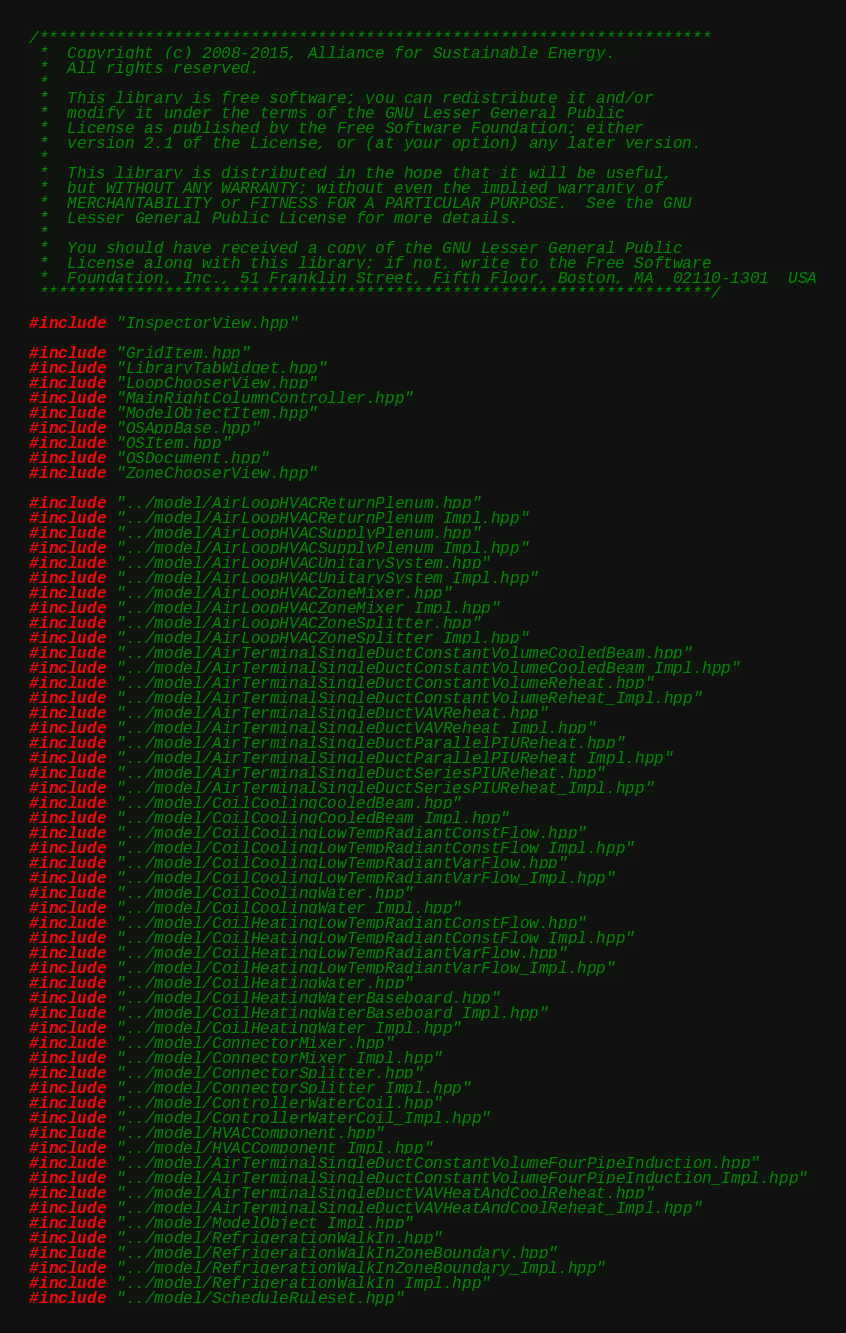Convert code to text. <code><loc_0><loc_0><loc_500><loc_500><_C++_>/**********************************************************************
 *  Copyright (c) 2008-2015, Alliance for Sustainable Energy.  
 *  All rights reserved.
 *  
 *  This library is free software; you can redistribute it and/or
 *  modify it under the terms of the GNU Lesser General Public
 *  License as published by the Free Software Foundation; either
 *  version 2.1 of the License, or (at your option) any later version.
 *  
 *  This library is distributed in the hope that it will be useful,
 *  but WITHOUT ANY WARRANTY; without even the implied warranty of
 *  MERCHANTABILITY or FITNESS FOR A PARTICULAR PURPOSE.  See the GNU
 *  Lesser General Public License for more details.
 *  
 *  You should have received a copy of the GNU Lesser General Public
 *  License along with this library; if not, write to the Free Software
 *  Foundation, Inc., 51 Franklin Street, Fifth Floor, Boston, MA  02110-1301  USA
 **********************************************************************/

#include "InspectorView.hpp"

#include "GridItem.hpp"
#include "LibraryTabWidget.hpp"
#include "LoopChooserView.hpp"
#include "MainRightColumnController.hpp"
#include "ModelObjectItem.hpp"
#include "OSAppBase.hpp"
#include "OSItem.hpp"
#include "OSDocument.hpp"
#include "ZoneChooserView.hpp"

#include "../model/AirLoopHVACReturnPlenum.hpp"
#include "../model/AirLoopHVACReturnPlenum_Impl.hpp"
#include "../model/AirLoopHVACSupplyPlenum.hpp"
#include "../model/AirLoopHVACSupplyPlenum_Impl.hpp"
#include "../model/AirLoopHVACUnitarySystem.hpp"
#include "../model/AirLoopHVACUnitarySystem_Impl.hpp"
#include "../model/AirLoopHVACZoneMixer.hpp"
#include "../model/AirLoopHVACZoneMixer_Impl.hpp"
#include "../model/AirLoopHVACZoneSplitter.hpp"
#include "../model/AirLoopHVACZoneSplitter_Impl.hpp"
#include "../model/AirTerminalSingleDuctConstantVolumeCooledBeam.hpp"
#include "../model/AirTerminalSingleDuctConstantVolumeCooledBeam_Impl.hpp"
#include "../model/AirTerminalSingleDuctConstantVolumeReheat.hpp"
#include "../model/AirTerminalSingleDuctConstantVolumeReheat_Impl.hpp"
#include "../model/AirTerminalSingleDuctVAVReheat.hpp"
#include "../model/AirTerminalSingleDuctVAVReheat_Impl.hpp"
#include "../model/AirTerminalSingleDuctParallelPIUReheat.hpp"
#include "../model/AirTerminalSingleDuctParallelPIUReheat_Impl.hpp"
#include "../model/AirTerminalSingleDuctSeriesPIUReheat.hpp"
#include "../model/AirTerminalSingleDuctSeriesPIUReheat_Impl.hpp"
#include "../model/CoilCoolingCooledBeam.hpp"
#include "../model/CoilCoolingCooledBeam_Impl.hpp"
#include "../model/CoilCoolingLowTempRadiantConstFlow.hpp"
#include "../model/CoilCoolingLowTempRadiantConstFlow_Impl.hpp"
#include "../model/CoilCoolingLowTempRadiantVarFlow.hpp"
#include "../model/CoilCoolingLowTempRadiantVarFlow_Impl.hpp"
#include "../model/CoilCoolingWater.hpp"
#include "../model/CoilCoolingWater_Impl.hpp"
#include "../model/CoilHeatingLowTempRadiantConstFlow.hpp"
#include "../model/CoilHeatingLowTempRadiantConstFlow_Impl.hpp"
#include "../model/CoilHeatingLowTempRadiantVarFlow.hpp"
#include "../model/CoilHeatingLowTempRadiantVarFlow_Impl.hpp"
#include "../model/CoilHeatingWater.hpp"
#include "../model/CoilHeatingWaterBaseboard.hpp"
#include "../model/CoilHeatingWaterBaseboard_Impl.hpp"
#include "../model/CoilHeatingWater_Impl.hpp"
#include "../model/ConnectorMixer.hpp"
#include "../model/ConnectorMixer_Impl.hpp"
#include "../model/ConnectorSplitter.hpp"
#include "../model/ConnectorSplitter_Impl.hpp"
#include "../model/ControllerWaterCoil.hpp"
#include "../model/ControllerWaterCoil_Impl.hpp"
#include "../model/HVACComponent.hpp"
#include "../model/HVACComponent_Impl.hpp"
#include "../model/AirTerminalSingleDuctConstantVolumeFourPipeInduction.hpp"
#include "../model/AirTerminalSingleDuctConstantVolumeFourPipeInduction_Impl.hpp"
#include "../model/AirTerminalSingleDuctVAVHeatAndCoolReheat.hpp"
#include "../model/AirTerminalSingleDuctVAVHeatAndCoolReheat_Impl.hpp"
#include "../model/ModelObject_Impl.hpp"
#include "../model/RefrigerationWalkIn.hpp"
#include "../model/RefrigerationWalkInZoneBoundary.hpp"
#include "../model/RefrigerationWalkInZoneBoundary_Impl.hpp"
#include "../model/RefrigerationWalkIn_Impl.hpp"
#include "../model/ScheduleRuleset.hpp"</code> 